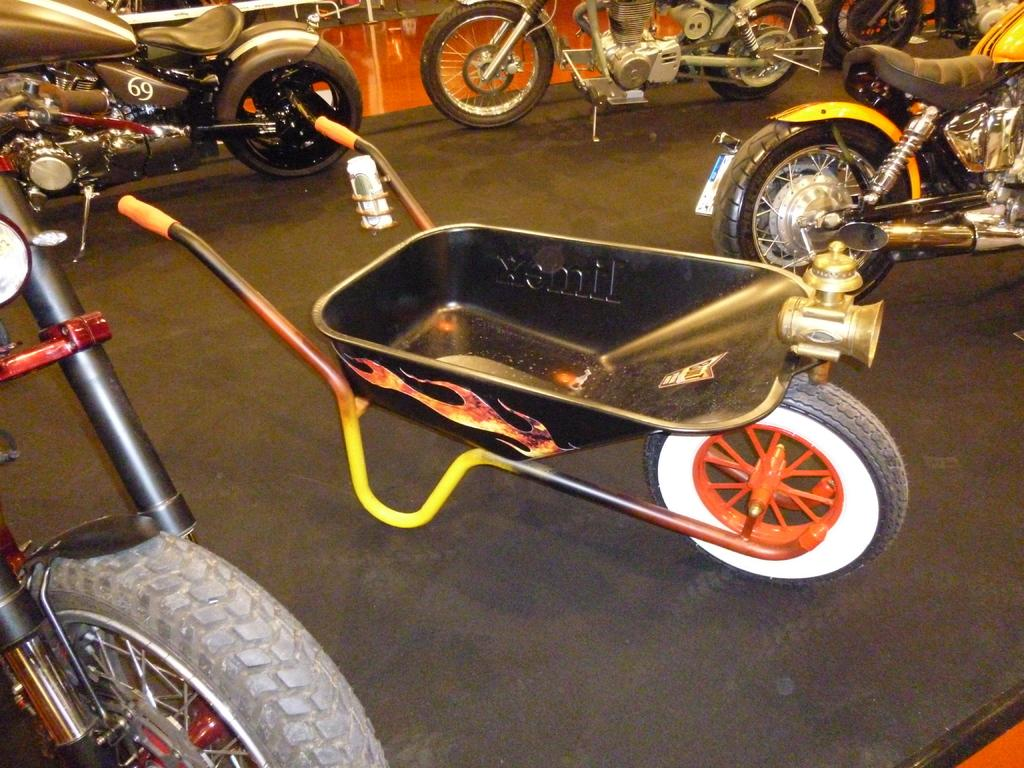What type of vehicles are present in the image? There are motorbikes in the image. Can you describe another object in the image? There is an object that looks like a trolley in the image. What can be seen in the background of the image? There is a wall visible in the background of the image. What type of surprise can be seen on the motorbikes in the image? There is no surprise present on the motorbikes in the image. Can you tell me how many bikes are visible in the image? The term "bike" is not mentioned in the provided facts, but there are motorbikes visible in the image. 